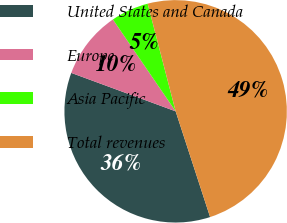Convert chart to OTSL. <chart><loc_0><loc_0><loc_500><loc_500><pie_chart><fcel>United States and Canada<fcel>Europe<fcel>Asia Pacific<fcel>Total revenues<nl><fcel>35.63%<fcel>9.85%<fcel>5.49%<fcel>49.03%<nl></chart> 